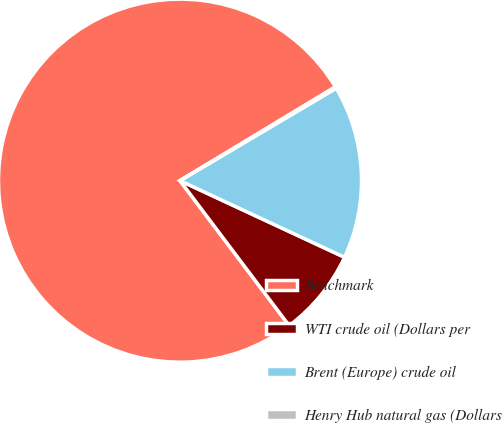Convert chart. <chart><loc_0><loc_0><loc_500><loc_500><pie_chart><fcel>Benchmark<fcel>WTI crude oil (Dollars per<fcel>Brent (Europe) crude oil<fcel>Henry Hub natural gas (Dollars<nl><fcel>76.63%<fcel>7.79%<fcel>15.44%<fcel>0.14%<nl></chart> 